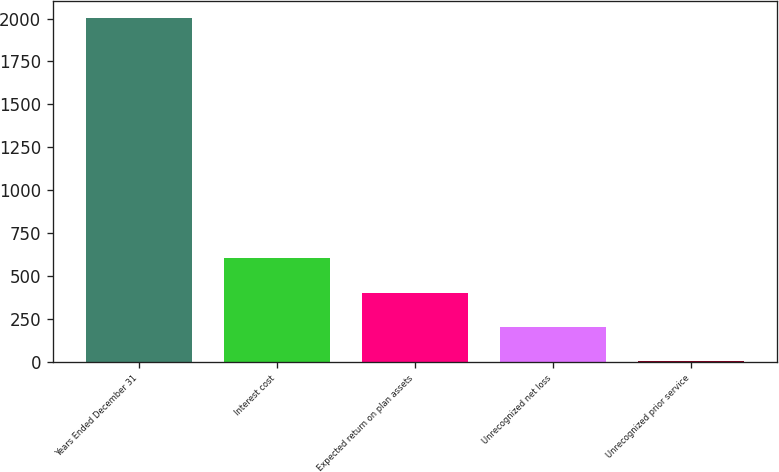Convert chart to OTSL. <chart><loc_0><loc_0><loc_500><loc_500><bar_chart><fcel>Years Ended December 31<fcel>Interest cost<fcel>Expected return on plan assets<fcel>Unrecognized net loss<fcel>Unrecognized prior service<nl><fcel>2005<fcel>603.6<fcel>403.4<fcel>203.2<fcel>3<nl></chart> 